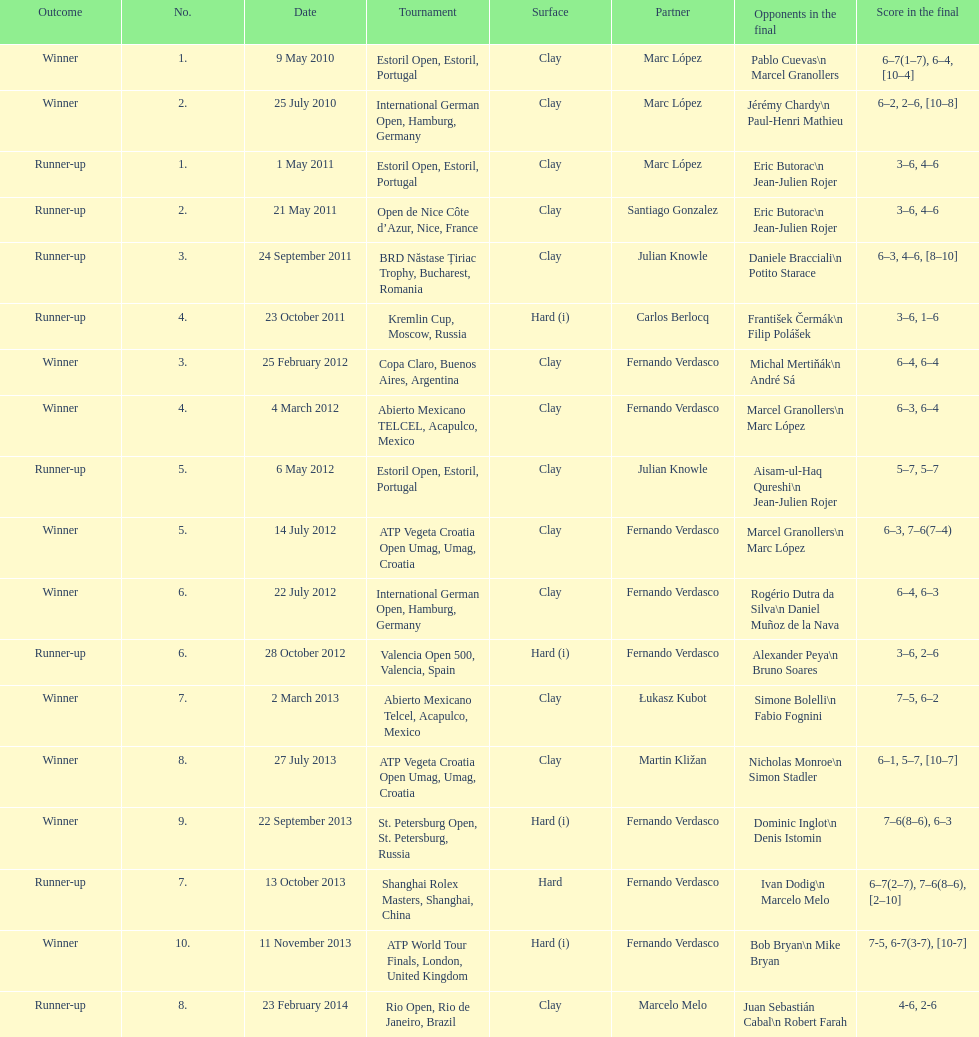What is the number of times a hard surface was used? 5. 